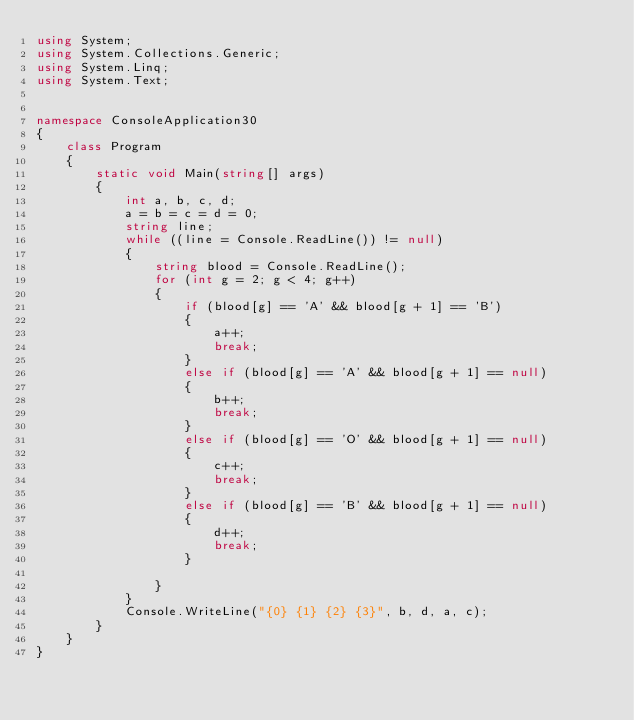Convert code to text. <code><loc_0><loc_0><loc_500><loc_500><_C#_>using System;
using System.Collections.Generic;
using System.Linq;
using System.Text;


namespace ConsoleApplication30
{
    class Program
    {
        static void Main(string[] args)
        {
            int a, b, c, d;
            a = b = c = d = 0;
            string line;
            while ((line = Console.ReadLine()) != null)
            {
                string blood = Console.ReadLine();
                for (int g = 2; g < 4; g++)
                {
                    if (blood[g] == 'A' && blood[g + 1] == 'B')
                    {
                        a++;
                        break;
                    }
                    else if (blood[g] == 'A' && blood[g + 1] == null)
                    {
                        b++;
                        break;
                    }
                    else if (blood[g] == 'O' && blood[g + 1] == null)
                    {
                        c++;
                        break;
                    }
                    else if (blood[g] == 'B' && blood[g + 1] == null)
                    {
                        d++;
                        break;
                    }

                }
            }
            Console.WriteLine("{0} {1} {2} {3}", b, d, a, c);
        }
    }
}</code> 